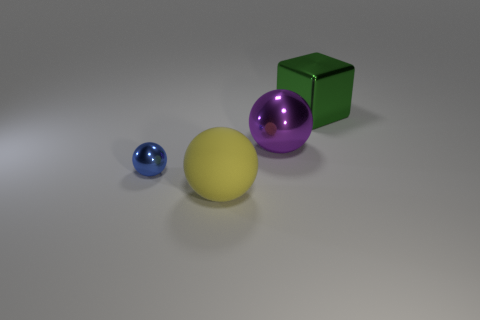What size is the object to the right of the large metallic thing that is on the left side of the large cube?
Your response must be concise. Large. Are there any big purple spheres that have the same material as the tiny blue ball?
Offer a terse response. Yes. What is the material of the green block that is the same size as the purple ball?
Give a very brief answer. Metal. Is the color of the large metallic object behind the purple metal thing the same as the big metallic thing left of the green shiny object?
Keep it short and to the point. No. There is a large metal object in front of the metallic block; are there any rubber spheres that are behind it?
Keep it short and to the point. No. There is a big object that is in front of the blue thing; is its shape the same as the large metal object in front of the big green metallic thing?
Make the answer very short. Yes. Does the thing that is to the right of the big purple ball have the same material as the thing that is on the left side of the large yellow object?
Your answer should be compact. Yes. The large sphere that is behind the large yellow object on the left side of the purple sphere is made of what material?
Your answer should be very brief. Metal. There is a object that is on the left side of the large sphere in front of the big metallic object that is in front of the green block; what shape is it?
Offer a very short reply. Sphere. There is another yellow object that is the same shape as the tiny metallic object; what is it made of?
Your response must be concise. Rubber. 